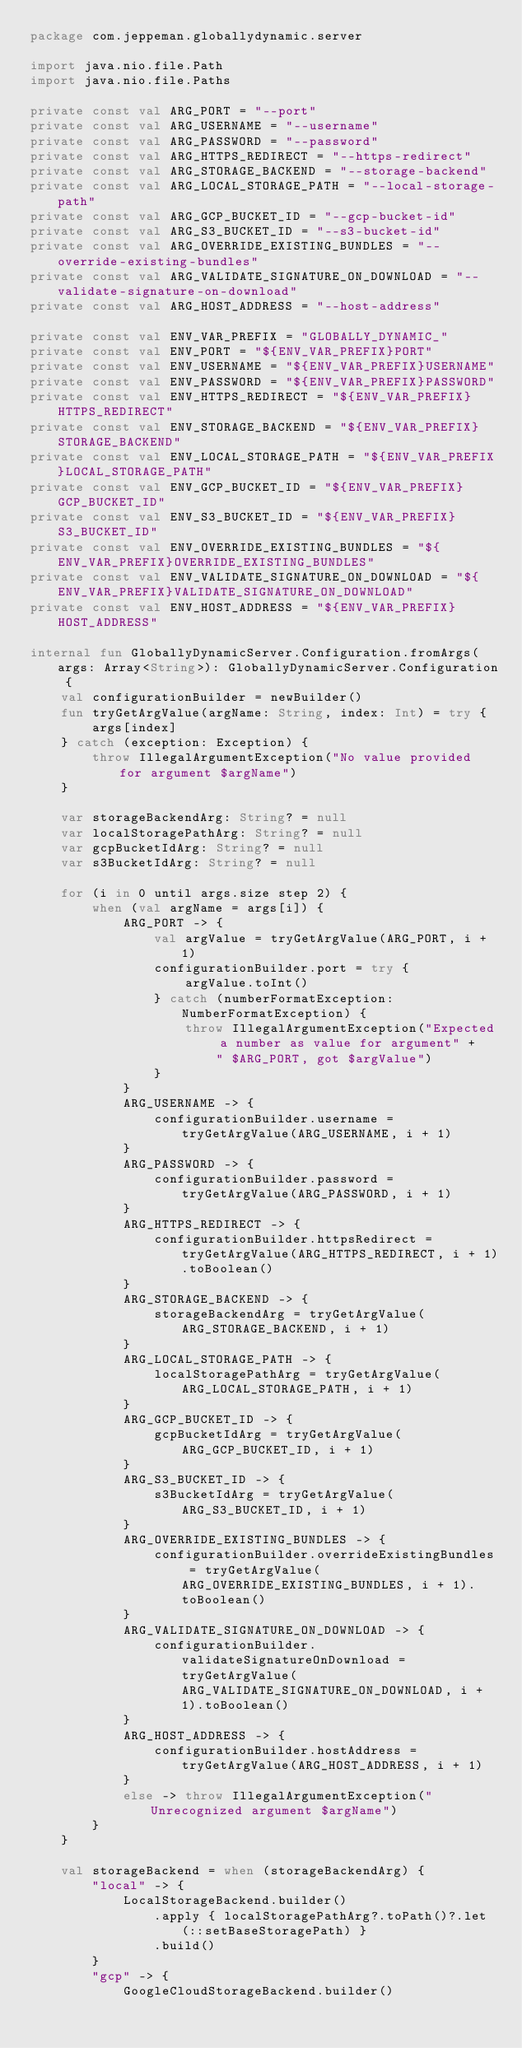<code> <loc_0><loc_0><loc_500><loc_500><_Kotlin_>package com.jeppeman.globallydynamic.server

import java.nio.file.Path
import java.nio.file.Paths

private const val ARG_PORT = "--port"
private const val ARG_USERNAME = "--username"
private const val ARG_PASSWORD = "--password"
private const val ARG_HTTPS_REDIRECT = "--https-redirect"
private const val ARG_STORAGE_BACKEND = "--storage-backend"
private const val ARG_LOCAL_STORAGE_PATH = "--local-storage-path"
private const val ARG_GCP_BUCKET_ID = "--gcp-bucket-id"
private const val ARG_S3_BUCKET_ID = "--s3-bucket-id"
private const val ARG_OVERRIDE_EXISTING_BUNDLES = "--override-existing-bundles"
private const val ARG_VALIDATE_SIGNATURE_ON_DOWNLOAD = "--validate-signature-on-download"
private const val ARG_HOST_ADDRESS = "--host-address"

private const val ENV_VAR_PREFIX = "GLOBALLY_DYNAMIC_"
private const val ENV_PORT = "${ENV_VAR_PREFIX}PORT"
private const val ENV_USERNAME = "${ENV_VAR_PREFIX}USERNAME"
private const val ENV_PASSWORD = "${ENV_VAR_PREFIX}PASSWORD"
private const val ENV_HTTPS_REDIRECT = "${ENV_VAR_PREFIX}HTTPS_REDIRECT"
private const val ENV_STORAGE_BACKEND = "${ENV_VAR_PREFIX}STORAGE_BACKEND"
private const val ENV_LOCAL_STORAGE_PATH = "${ENV_VAR_PREFIX}LOCAL_STORAGE_PATH"
private const val ENV_GCP_BUCKET_ID = "${ENV_VAR_PREFIX}GCP_BUCKET_ID"
private const val ENV_S3_BUCKET_ID = "${ENV_VAR_PREFIX}S3_BUCKET_ID"
private const val ENV_OVERRIDE_EXISTING_BUNDLES = "${ENV_VAR_PREFIX}OVERRIDE_EXISTING_BUNDLES"
private const val ENV_VALIDATE_SIGNATURE_ON_DOWNLOAD = "${ENV_VAR_PREFIX}VALIDATE_SIGNATURE_ON_DOWNLOAD"
private const val ENV_HOST_ADDRESS = "${ENV_VAR_PREFIX}HOST_ADDRESS"

internal fun GloballyDynamicServer.Configuration.fromArgs(args: Array<String>): GloballyDynamicServer.Configuration {
    val configurationBuilder = newBuilder()
    fun tryGetArgValue(argName: String, index: Int) = try {
        args[index]
    } catch (exception: Exception) {
        throw IllegalArgumentException("No value provided for argument $argName")
    }

    var storageBackendArg: String? = null
    var localStoragePathArg: String? = null
    var gcpBucketIdArg: String? = null
    var s3BucketIdArg: String? = null

    for (i in 0 until args.size step 2) {
        when (val argName = args[i]) {
            ARG_PORT -> {
                val argValue = tryGetArgValue(ARG_PORT, i + 1)
                configurationBuilder.port = try {
                    argValue.toInt()
                } catch (numberFormatException: NumberFormatException) {
                    throw IllegalArgumentException("Expected a number as value for argument" +
                        " $ARG_PORT, got $argValue")
                }
            }
            ARG_USERNAME -> {
                configurationBuilder.username = tryGetArgValue(ARG_USERNAME, i + 1)
            }
            ARG_PASSWORD -> {
                configurationBuilder.password = tryGetArgValue(ARG_PASSWORD, i + 1)
            }
            ARG_HTTPS_REDIRECT -> {
                configurationBuilder.httpsRedirect = tryGetArgValue(ARG_HTTPS_REDIRECT, i + 1).toBoolean()
            }
            ARG_STORAGE_BACKEND -> {
                storageBackendArg = tryGetArgValue(ARG_STORAGE_BACKEND, i + 1)
            }
            ARG_LOCAL_STORAGE_PATH -> {
                localStoragePathArg = tryGetArgValue(ARG_LOCAL_STORAGE_PATH, i + 1)
            }
            ARG_GCP_BUCKET_ID -> {
                gcpBucketIdArg = tryGetArgValue(ARG_GCP_BUCKET_ID, i + 1)
            }
            ARG_S3_BUCKET_ID -> {
                s3BucketIdArg = tryGetArgValue(ARG_S3_BUCKET_ID, i + 1)
            }
            ARG_OVERRIDE_EXISTING_BUNDLES -> {
                configurationBuilder.overrideExistingBundles = tryGetArgValue(ARG_OVERRIDE_EXISTING_BUNDLES, i + 1).toBoolean()
            }
            ARG_VALIDATE_SIGNATURE_ON_DOWNLOAD -> {
                configurationBuilder.validateSignatureOnDownload = tryGetArgValue(ARG_VALIDATE_SIGNATURE_ON_DOWNLOAD, i + 1).toBoolean()
            }
            ARG_HOST_ADDRESS -> {
                configurationBuilder.hostAddress = tryGetArgValue(ARG_HOST_ADDRESS, i + 1)
            }
            else -> throw IllegalArgumentException("Unrecognized argument $argName")
        }
    }

    val storageBackend = when (storageBackendArg) {
        "local" -> {
            LocalStorageBackend.builder()
                .apply { localStoragePathArg?.toPath()?.let(::setBaseStoragePath) }
                .build()
        }
        "gcp" -> {
            GoogleCloudStorageBackend.builder()</code> 